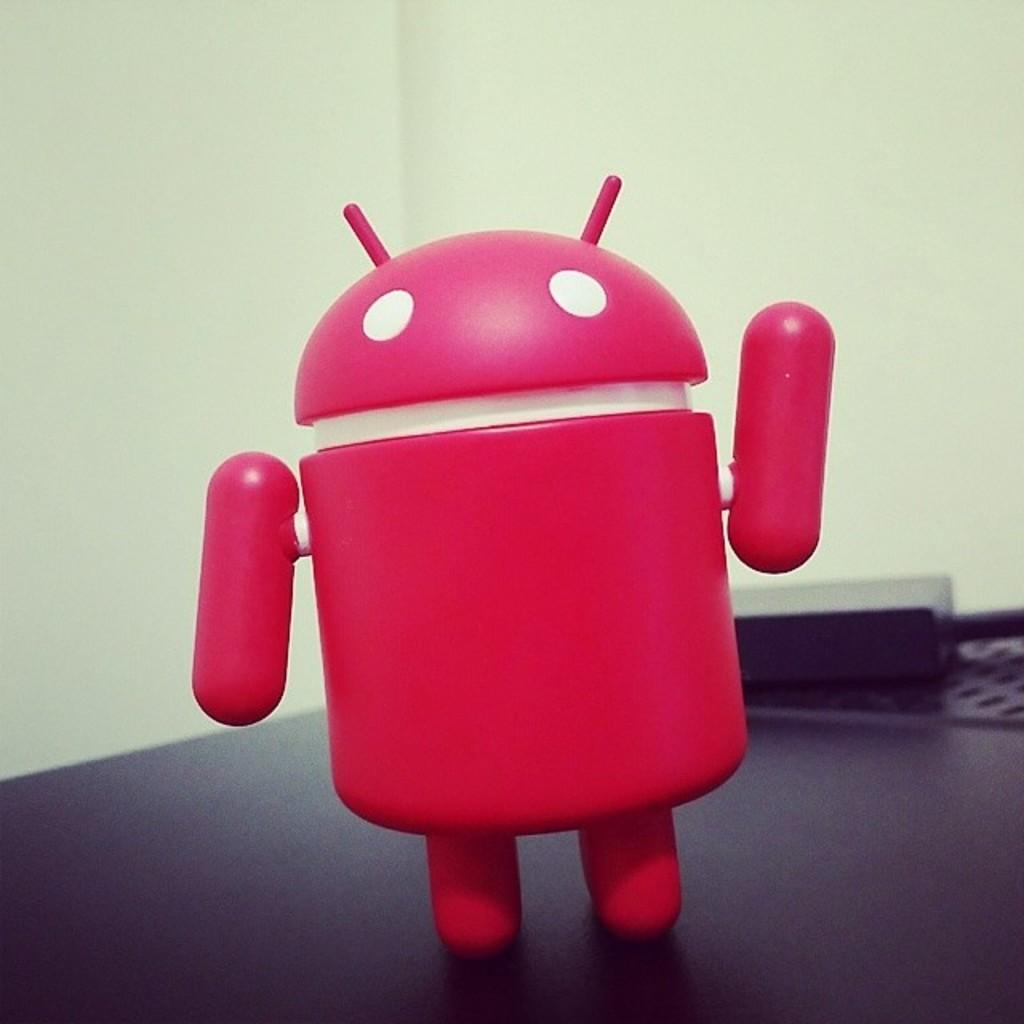What is the main object in the image? There is a table in the image. What is placed on the table? There is a toy on the table. What can be seen in the background of the image? There is a wall in the background of the image. What time of day is it in the image? The time of day cannot be determined from the image, as there are no clues or indicators present. 